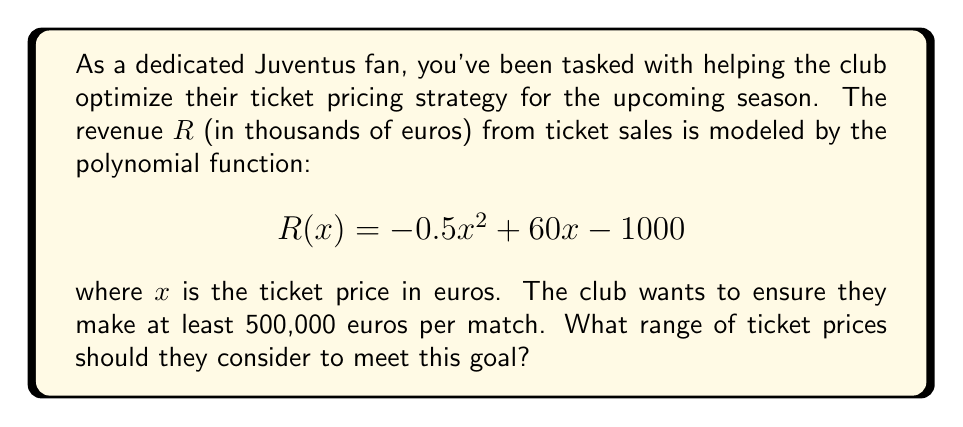Can you answer this question? Let's approach this step-by-step:

1) We need to find the values of x where R(x) ≥ 500, as 500 thousand euros is 500,000 euros.

2) Set up the inequality:
   $$-0.5x^2 + 60x - 1000 \geq 500$$

3) Rearrange the inequality:
   $$-0.5x^2 + 60x - 1500 \geq 0$$

4) Multiply everything by -2 to make the coefficient of $x^2$ positive. Remember to flip the inequality sign:
   $$x^2 - 120x + 3000 \leq 0$$

5) This is a quadratic inequality. To solve it, we first need to find the roots of the quadratic equation:
   $$x^2 - 120x + 3000 = 0$$

6) Using the quadratic formula, $x = \frac{-b \pm \sqrt{b^2 - 4ac}}{2a}$, where a = 1, b = -120, and c = 3000:

   $$x = \frac{120 \pm \sqrt{120^2 - 4(1)(3000)}}{2(1)}$$
   $$x = \frac{120 \pm \sqrt{14400 - 12000}}{2}$$
   $$x = \frac{120 \pm \sqrt{2400}}{2}$$
   $$x = \frac{120 \pm 48.99}{2}$$

7) This gives us two roots:
   $x_1 = \frac{120 + 48.99}{2} \approx 84.50$
   $x_2 = \frac{120 - 48.99}{2} \approx 35.50$

8) For a quadratic inequality of the form $ax^2 + bx + c \leq 0$ where a > 0, the solution is all x between the two roots.

Therefore, the range of ticket prices that will generate at least 500,000 euros per match is between 35.50 and 84.50 euros.
Answer: 35.50 ≤ x ≤ 84.50 